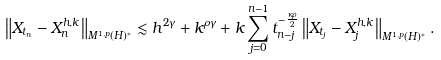<formula> <loc_0><loc_0><loc_500><loc_500>\left \| X _ { t _ { n } } - X _ { n } ^ { h , k } \right \| _ { M ^ { 1 , p } ( H ) ^ { * } } \lesssim h ^ { 2 \gamma } + k ^ { \rho \gamma } + k \sum _ { j = 0 } ^ { n - 1 } t _ { n - j } ^ { - \frac { \kappa \rho } 2 } \left \| X _ { t _ { j } } - X _ { j } ^ { h , k } \right \| _ { M ^ { 1 , p } ( H ) ^ { * } } .</formula> 